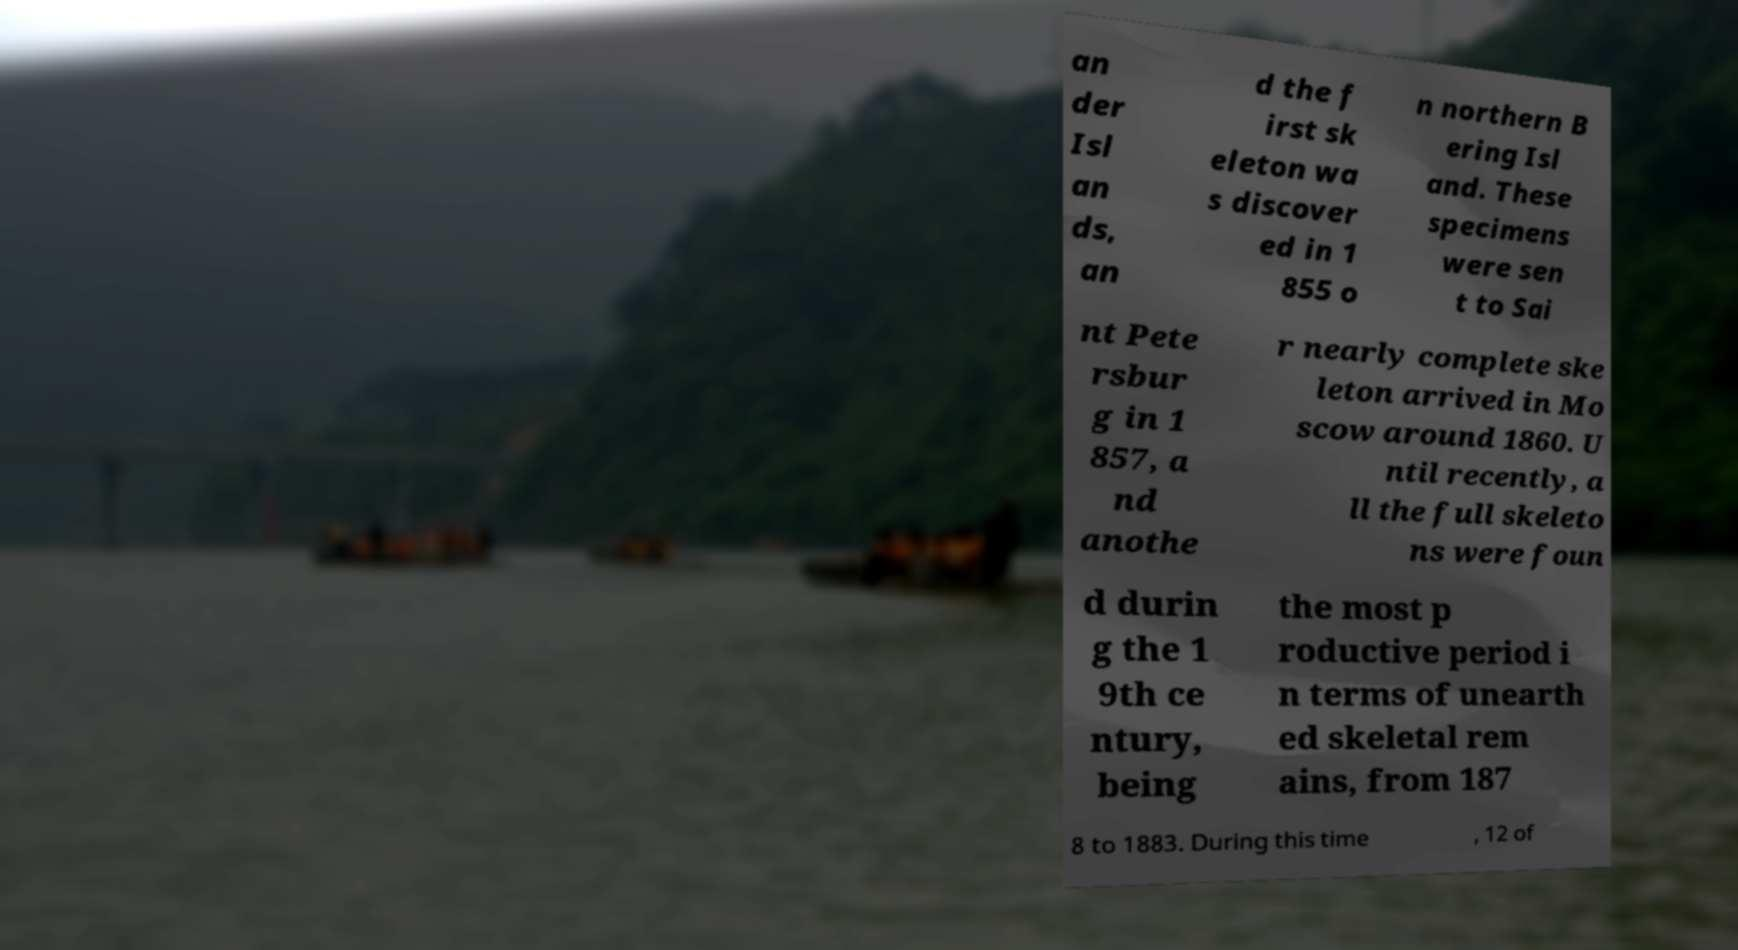Could you extract and type out the text from this image? an der Isl an ds, an d the f irst sk eleton wa s discover ed in 1 855 o n northern B ering Isl and. These specimens were sen t to Sai nt Pete rsbur g in 1 857, a nd anothe r nearly complete ske leton arrived in Mo scow around 1860. U ntil recently, a ll the full skeleto ns were foun d durin g the 1 9th ce ntury, being the most p roductive period i n terms of unearth ed skeletal rem ains, from 187 8 to 1883. During this time , 12 of 